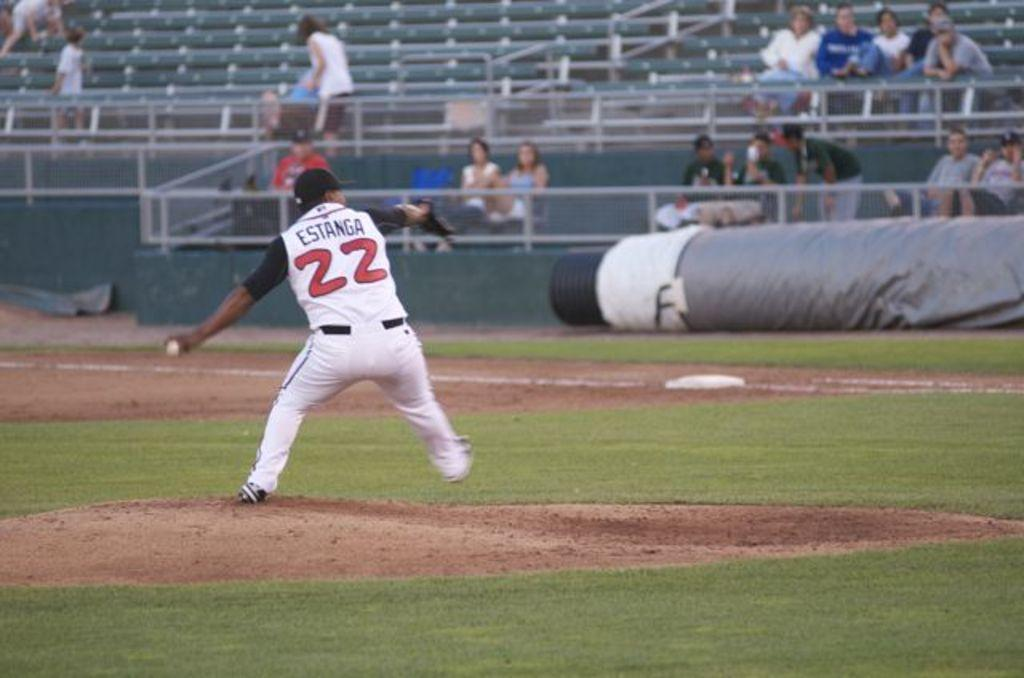<image>
Create a compact narrative representing the image presented. The player here who is about to throw the ball wears number 22. 